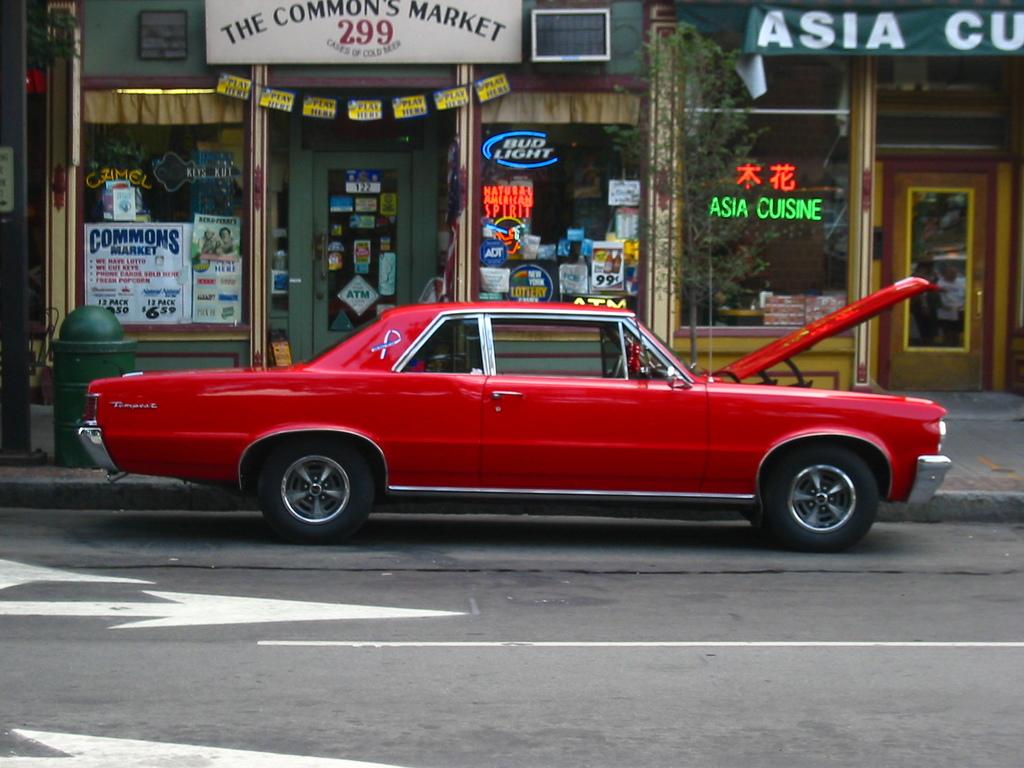What is the number of the commons market?
Offer a very short reply. 299. What is the name of the market?
Provide a short and direct response. The common's market. 